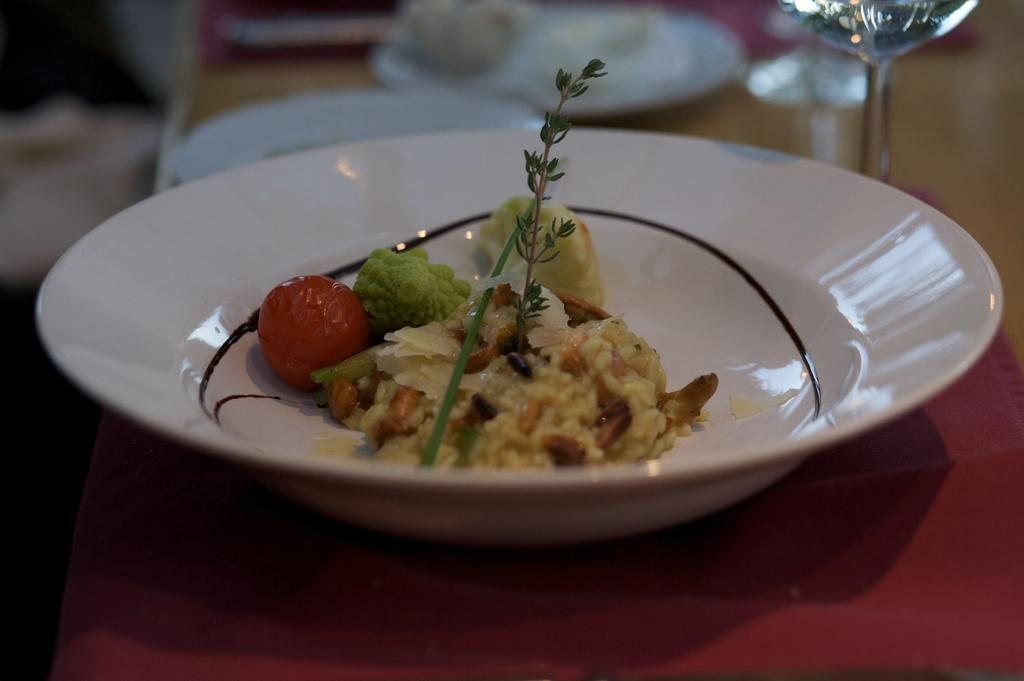What is on the table in the image? There is a bowl on the table in the image. What is inside the bowl? There is food in the bowl. Is there a fan blowing on the food in the image? There is no fan present in the image, so it cannot be determined if it is blowing on the food. 